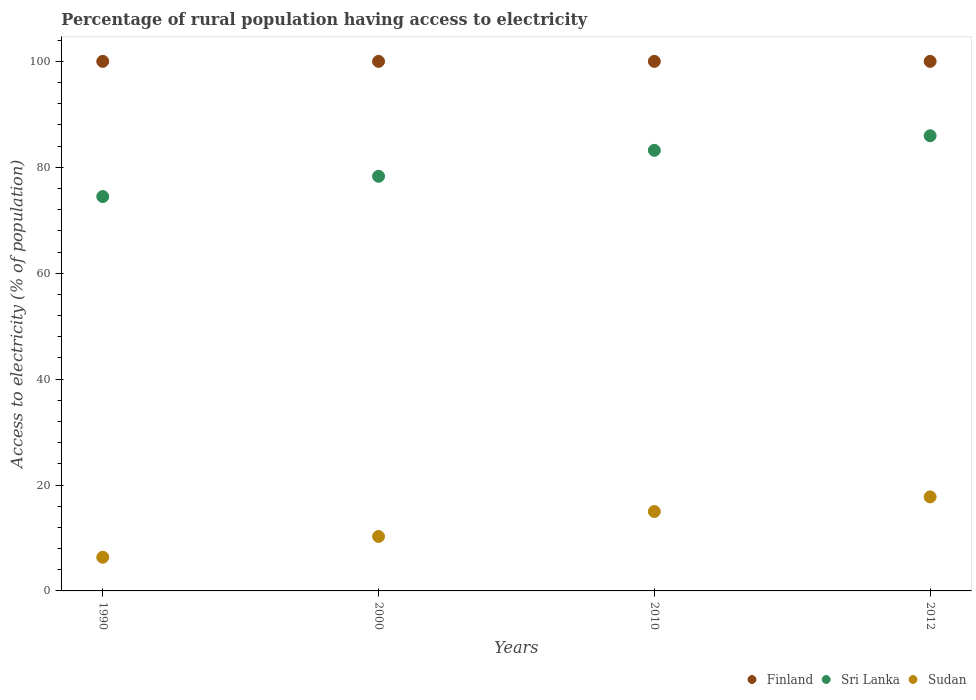How many different coloured dotlines are there?
Give a very brief answer. 3. Is the number of dotlines equal to the number of legend labels?
Offer a terse response. Yes. What is the percentage of rural population having access to electricity in Finland in 2010?
Make the answer very short. 100. Across all years, what is the maximum percentage of rural population having access to electricity in Finland?
Your answer should be compact. 100. Across all years, what is the minimum percentage of rural population having access to electricity in Sri Lanka?
Ensure brevity in your answer.  74.47. What is the total percentage of rural population having access to electricity in Sri Lanka in the graph?
Give a very brief answer. 321.92. What is the difference between the percentage of rural population having access to electricity in Sri Lanka in 1990 and that in 2012?
Offer a very short reply. -11.48. What is the difference between the percentage of rural population having access to electricity in Sri Lanka in 2000 and the percentage of rural population having access to electricity in Sudan in 2012?
Provide a short and direct response. 60.55. In the year 2012, what is the difference between the percentage of rural population having access to electricity in Sri Lanka and percentage of rural population having access to electricity in Finland?
Ensure brevity in your answer.  -14.05. Is the percentage of rural population having access to electricity in Sudan in 2010 less than that in 2012?
Your answer should be compact. Yes. What is the difference between the highest and the second highest percentage of rural population having access to electricity in Finland?
Ensure brevity in your answer.  0. What is the difference between the highest and the lowest percentage of rural population having access to electricity in Sri Lanka?
Your response must be concise. 11.48. Is the sum of the percentage of rural population having access to electricity in Finland in 2000 and 2012 greater than the maximum percentage of rural population having access to electricity in Sri Lanka across all years?
Your answer should be compact. Yes. Does the percentage of rural population having access to electricity in Sri Lanka monotonically increase over the years?
Your answer should be very brief. Yes. Is the percentage of rural population having access to electricity in Sudan strictly less than the percentage of rural population having access to electricity in Finland over the years?
Your answer should be compact. Yes. How many dotlines are there?
Provide a succinct answer. 3. What is the difference between two consecutive major ticks on the Y-axis?
Provide a short and direct response. 20. Are the values on the major ticks of Y-axis written in scientific E-notation?
Make the answer very short. No. Does the graph contain any zero values?
Your response must be concise. No. Where does the legend appear in the graph?
Provide a short and direct response. Bottom right. How many legend labels are there?
Provide a short and direct response. 3. What is the title of the graph?
Offer a very short reply. Percentage of rural population having access to electricity. What is the label or title of the X-axis?
Ensure brevity in your answer.  Years. What is the label or title of the Y-axis?
Give a very brief answer. Access to electricity (% of population). What is the Access to electricity (% of population) in Finland in 1990?
Your answer should be compact. 100. What is the Access to electricity (% of population) in Sri Lanka in 1990?
Provide a short and direct response. 74.47. What is the Access to electricity (% of population) in Sudan in 1990?
Your answer should be compact. 6.36. What is the Access to electricity (% of population) of Finland in 2000?
Make the answer very short. 100. What is the Access to electricity (% of population) in Sri Lanka in 2000?
Offer a very short reply. 78.3. What is the Access to electricity (% of population) of Sudan in 2000?
Provide a succinct answer. 10.28. What is the Access to electricity (% of population) of Sri Lanka in 2010?
Provide a short and direct response. 83.2. What is the Access to electricity (% of population) in Sri Lanka in 2012?
Your answer should be compact. 85.95. What is the Access to electricity (% of population) of Sudan in 2012?
Keep it short and to the point. 17.75. Across all years, what is the maximum Access to electricity (% of population) in Finland?
Offer a very short reply. 100. Across all years, what is the maximum Access to electricity (% of population) in Sri Lanka?
Your answer should be compact. 85.95. Across all years, what is the maximum Access to electricity (% of population) of Sudan?
Your answer should be compact. 17.75. Across all years, what is the minimum Access to electricity (% of population) in Sri Lanka?
Make the answer very short. 74.47. Across all years, what is the minimum Access to electricity (% of population) in Sudan?
Offer a terse response. 6.36. What is the total Access to electricity (% of population) in Sri Lanka in the graph?
Your response must be concise. 321.92. What is the total Access to electricity (% of population) in Sudan in the graph?
Offer a terse response. 49.4. What is the difference between the Access to electricity (% of population) of Finland in 1990 and that in 2000?
Keep it short and to the point. 0. What is the difference between the Access to electricity (% of population) in Sri Lanka in 1990 and that in 2000?
Ensure brevity in your answer.  -3.83. What is the difference between the Access to electricity (% of population) of Sudan in 1990 and that in 2000?
Offer a terse response. -3.92. What is the difference between the Access to electricity (% of population) of Sri Lanka in 1990 and that in 2010?
Offer a terse response. -8.73. What is the difference between the Access to electricity (% of population) in Sudan in 1990 and that in 2010?
Keep it short and to the point. -8.64. What is the difference between the Access to electricity (% of population) in Sri Lanka in 1990 and that in 2012?
Your answer should be compact. -11.48. What is the difference between the Access to electricity (% of population) of Sudan in 1990 and that in 2012?
Ensure brevity in your answer.  -11.39. What is the difference between the Access to electricity (% of population) of Sudan in 2000 and that in 2010?
Give a very brief answer. -4.72. What is the difference between the Access to electricity (% of population) of Finland in 2000 and that in 2012?
Your answer should be very brief. 0. What is the difference between the Access to electricity (% of population) in Sri Lanka in 2000 and that in 2012?
Provide a succinct answer. -7.65. What is the difference between the Access to electricity (% of population) in Sudan in 2000 and that in 2012?
Make the answer very short. -7.47. What is the difference between the Access to electricity (% of population) of Sri Lanka in 2010 and that in 2012?
Provide a succinct answer. -2.75. What is the difference between the Access to electricity (% of population) in Sudan in 2010 and that in 2012?
Your response must be concise. -2.75. What is the difference between the Access to electricity (% of population) in Finland in 1990 and the Access to electricity (% of population) in Sri Lanka in 2000?
Provide a succinct answer. 21.7. What is the difference between the Access to electricity (% of population) in Finland in 1990 and the Access to electricity (% of population) in Sudan in 2000?
Offer a terse response. 89.72. What is the difference between the Access to electricity (% of population) of Sri Lanka in 1990 and the Access to electricity (% of population) of Sudan in 2000?
Keep it short and to the point. 64.19. What is the difference between the Access to electricity (% of population) in Finland in 1990 and the Access to electricity (% of population) in Sri Lanka in 2010?
Offer a very short reply. 16.8. What is the difference between the Access to electricity (% of population) in Finland in 1990 and the Access to electricity (% of population) in Sudan in 2010?
Make the answer very short. 85. What is the difference between the Access to electricity (% of population) of Sri Lanka in 1990 and the Access to electricity (% of population) of Sudan in 2010?
Provide a succinct answer. 59.47. What is the difference between the Access to electricity (% of population) of Finland in 1990 and the Access to electricity (% of population) of Sri Lanka in 2012?
Your answer should be compact. 14.05. What is the difference between the Access to electricity (% of population) of Finland in 1990 and the Access to electricity (% of population) of Sudan in 2012?
Ensure brevity in your answer.  82.25. What is the difference between the Access to electricity (% of population) of Sri Lanka in 1990 and the Access to electricity (% of population) of Sudan in 2012?
Your answer should be very brief. 56.72. What is the difference between the Access to electricity (% of population) of Sri Lanka in 2000 and the Access to electricity (% of population) of Sudan in 2010?
Your response must be concise. 63.3. What is the difference between the Access to electricity (% of population) in Finland in 2000 and the Access to electricity (% of population) in Sri Lanka in 2012?
Ensure brevity in your answer.  14.05. What is the difference between the Access to electricity (% of population) of Finland in 2000 and the Access to electricity (% of population) of Sudan in 2012?
Your answer should be compact. 82.25. What is the difference between the Access to electricity (% of population) in Sri Lanka in 2000 and the Access to electricity (% of population) in Sudan in 2012?
Keep it short and to the point. 60.55. What is the difference between the Access to electricity (% of population) of Finland in 2010 and the Access to electricity (% of population) of Sri Lanka in 2012?
Ensure brevity in your answer.  14.05. What is the difference between the Access to electricity (% of population) in Finland in 2010 and the Access to electricity (% of population) in Sudan in 2012?
Keep it short and to the point. 82.25. What is the difference between the Access to electricity (% of population) in Sri Lanka in 2010 and the Access to electricity (% of population) in Sudan in 2012?
Make the answer very short. 65.45. What is the average Access to electricity (% of population) of Finland per year?
Offer a terse response. 100. What is the average Access to electricity (% of population) of Sri Lanka per year?
Give a very brief answer. 80.48. What is the average Access to electricity (% of population) in Sudan per year?
Your answer should be compact. 12.35. In the year 1990, what is the difference between the Access to electricity (% of population) of Finland and Access to electricity (% of population) of Sri Lanka?
Offer a terse response. 25.53. In the year 1990, what is the difference between the Access to electricity (% of population) of Finland and Access to electricity (% of population) of Sudan?
Ensure brevity in your answer.  93.64. In the year 1990, what is the difference between the Access to electricity (% of population) in Sri Lanka and Access to electricity (% of population) in Sudan?
Offer a very short reply. 68.11. In the year 2000, what is the difference between the Access to electricity (% of population) in Finland and Access to electricity (% of population) in Sri Lanka?
Offer a terse response. 21.7. In the year 2000, what is the difference between the Access to electricity (% of population) in Finland and Access to electricity (% of population) in Sudan?
Keep it short and to the point. 89.72. In the year 2000, what is the difference between the Access to electricity (% of population) in Sri Lanka and Access to electricity (% of population) in Sudan?
Offer a very short reply. 68.02. In the year 2010, what is the difference between the Access to electricity (% of population) in Finland and Access to electricity (% of population) in Sri Lanka?
Provide a succinct answer. 16.8. In the year 2010, what is the difference between the Access to electricity (% of population) in Sri Lanka and Access to electricity (% of population) in Sudan?
Ensure brevity in your answer.  68.2. In the year 2012, what is the difference between the Access to electricity (% of population) of Finland and Access to electricity (% of population) of Sri Lanka?
Your answer should be very brief. 14.05. In the year 2012, what is the difference between the Access to electricity (% of population) of Finland and Access to electricity (% of population) of Sudan?
Provide a short and direct response. 82.25. In the year 2012, what is the difference between the Access to electricity (% of population) in Sri Lanka and Access to electricity (% of population) in Sudan?
Make the answer very short. 68.2. What is the ratio of the Access to electricity (% of population) in Finland in 1990 to that in 2000?
Ensure brevity in your answer.  1. What is the ratio of the Access to electricity (% of population) of Sri Lanka in 1990 to that in 2000?
Ensure brevity in your answer.  0.95. What is the ratio of the Access to electricity (% of population) in Sudan in 1990 to that in 2000?
Offer a terse response. 0.62. What is the ratio of the Access to electricity (% of population) in Sri Lanka in 1990 to that in 2010?
Your answer should be very brief. 0.9. What is the ratio of the Access to electricity (% of population) in Sudan in 1990 to that in 2010?
Offer a terse response. 0.42. What is the ratio of the Access to electricity (% of population) of Sri Lanka in 1990 to that in 2012?
Keep it short and to the point. 0.87. What is the ratio of the Access to electricity (% of population) of Sudan in 1990 to that in 2012?
Give a very brief answer. 0.36. What is the ratio of the Access to electricity (% of population) in Finland in 2000 to that in 2010?
Your answer should be compact. 1. What is the ratio of the Access to electricity (% of population) of Sri Lanka in 2000 to that in 2010?
Ensure brevity in your answer.  0.94. What is the ratio of the Access to electricity (% of population) in Sudan in 2000 to that in 2010?
Your answer should be compact. 0.69. What is the ratio of the Access to electricity (% of population) of Finland in 2000 to that in 2012?
Provide a succinct answer. 1. What is the ratio of the Access to electricity (% of population) of Sri Lanka in 2000 to that in 2012?
Your answer should be very brief. 0.91. What is the ratio of the Access to electricity (% of population) in Sudan in 2000 to that in 2012?
Your answer should be very brief. 0.58. What is the ratio of the Access to electricity (% of population) in Sudan in 2010 to that in 2012?
Ensure brevity in your answer.  0.84. What is the difference between the highest and the second highest Access to electricity (% of population) in Finland?
Your answer should be very brief. 0. What is the difference between the highest and the second highest Access to electricity (% of population) in Sri Lanka?
Offer a terse response. 2.75. What is the difference between the highest and the second highest Access to electricity (% of population) of Sudan?
Ensure brevity in your answer.  2.75. What is the difference between the highest and the lowest Access to electricity (% of population) in Sri Lanka?
Ensure brevity in your answer.  11.48. What is the difference between the highest and the lowest Access to electricity (% of population) in Sudan?
Provide a short and direct response. 11.39. 